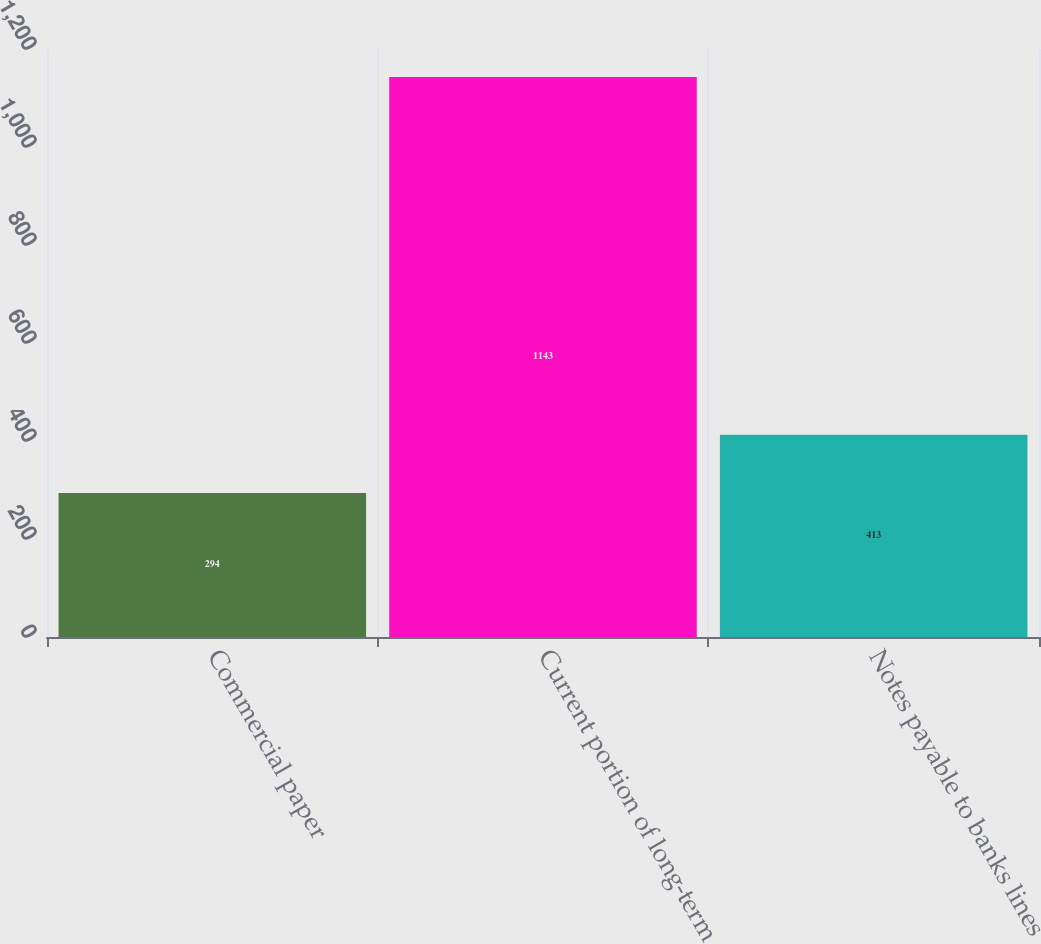Convert chart. <chart><loc_0><loc_0><loc_500><loc_500><bar_chart><fcel>Commercial paper<fcel>Current portion of long-term<fcel>Notes payable to banks lines<nl><fcel>294<fcel>1143<fcel>413<nl></chart> 